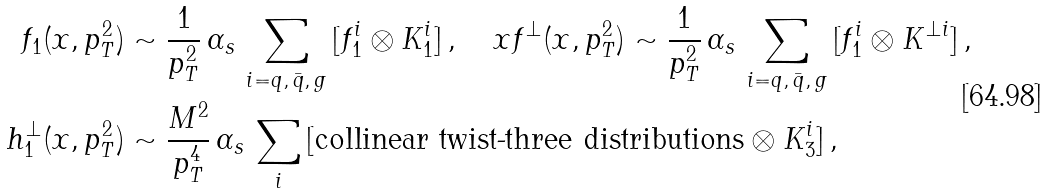<formula> <loc_0><loc_0><loc_500><loc_500>f _ { 1 } ( x , p _ { T } ^ { 2 } ) & \sim \frac { 1 } { p _ { T } ^ { 2 } } \, \alpha _ { s } \, \sum _ { i = q , \, \bar { q } , \, g } \, [ f _ { 1 } ^ { i } \otimes K _ { 1 } ^ { i } ] \, , \quad x f ^ { \perp } ( x , p _ { T } ^ { 2 } ) \sim \frac { 1 } { p _ { T } ^ { 2 } } \, \alpha _ { s } \, \sum _ { i = q , \, \bar { q } , \, g } \, [ f _ { 1 } ^ { i } \otimes K ^ { \perp i } ] \, , \\ h _ { 1 } ^ { \perp } ( x , p _ { T } ^ { 2 } ) & \sim \frac { M ^ { 2 } } { p _ { T } ^ { 4 } } \, \alpha _ { s } \, \sum _ { i } \, [ \text {collinear twist-three distributions} \otimes K _ { 3 } ^ { i } ] \, ,</formula> 